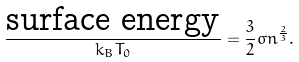Convert formula to latex. <formula><loc_0><loc_0><loc_500><loc_500>\frac { \text {surface energy} } { k _ { B } T _ { 0 } } = \frac { 3 } { 2 } \sigma n ^ { \frac { 2 } { 3 } } .</formula> 